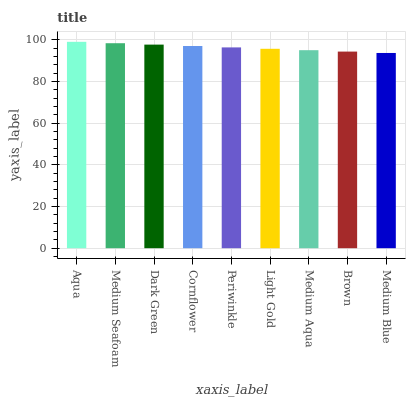Is Medium Blue the minimum?
Answer yes or no. Yes. Is Aqua the maximum?
Answer yes or no. Yes. Is Medium Seafoam the minimum?
Answer yes or no. No. Is Medium Seafoam the maximum?
Answer yes or no. No. Is Aqua greater than Medium Seafoam?
Answer yes or no. Yes. Is Medium Seafoam less than Aqua?
Answer yes or no. Yes. Is Medium Seafoam greater than Aqua?
Answer yes or no. No. Is Aqua less than Medium Seafoam?
Answer yes or no. No. Is Periwinkle the high median?
Answer yes or no. Yes. Is Periwinkle the low median?
Answer yes or no. Yes. Is Medium Seafoam the high median?
Answer yes or no. No. Is Medium Blue the low median?
Answer yes or no. No. 